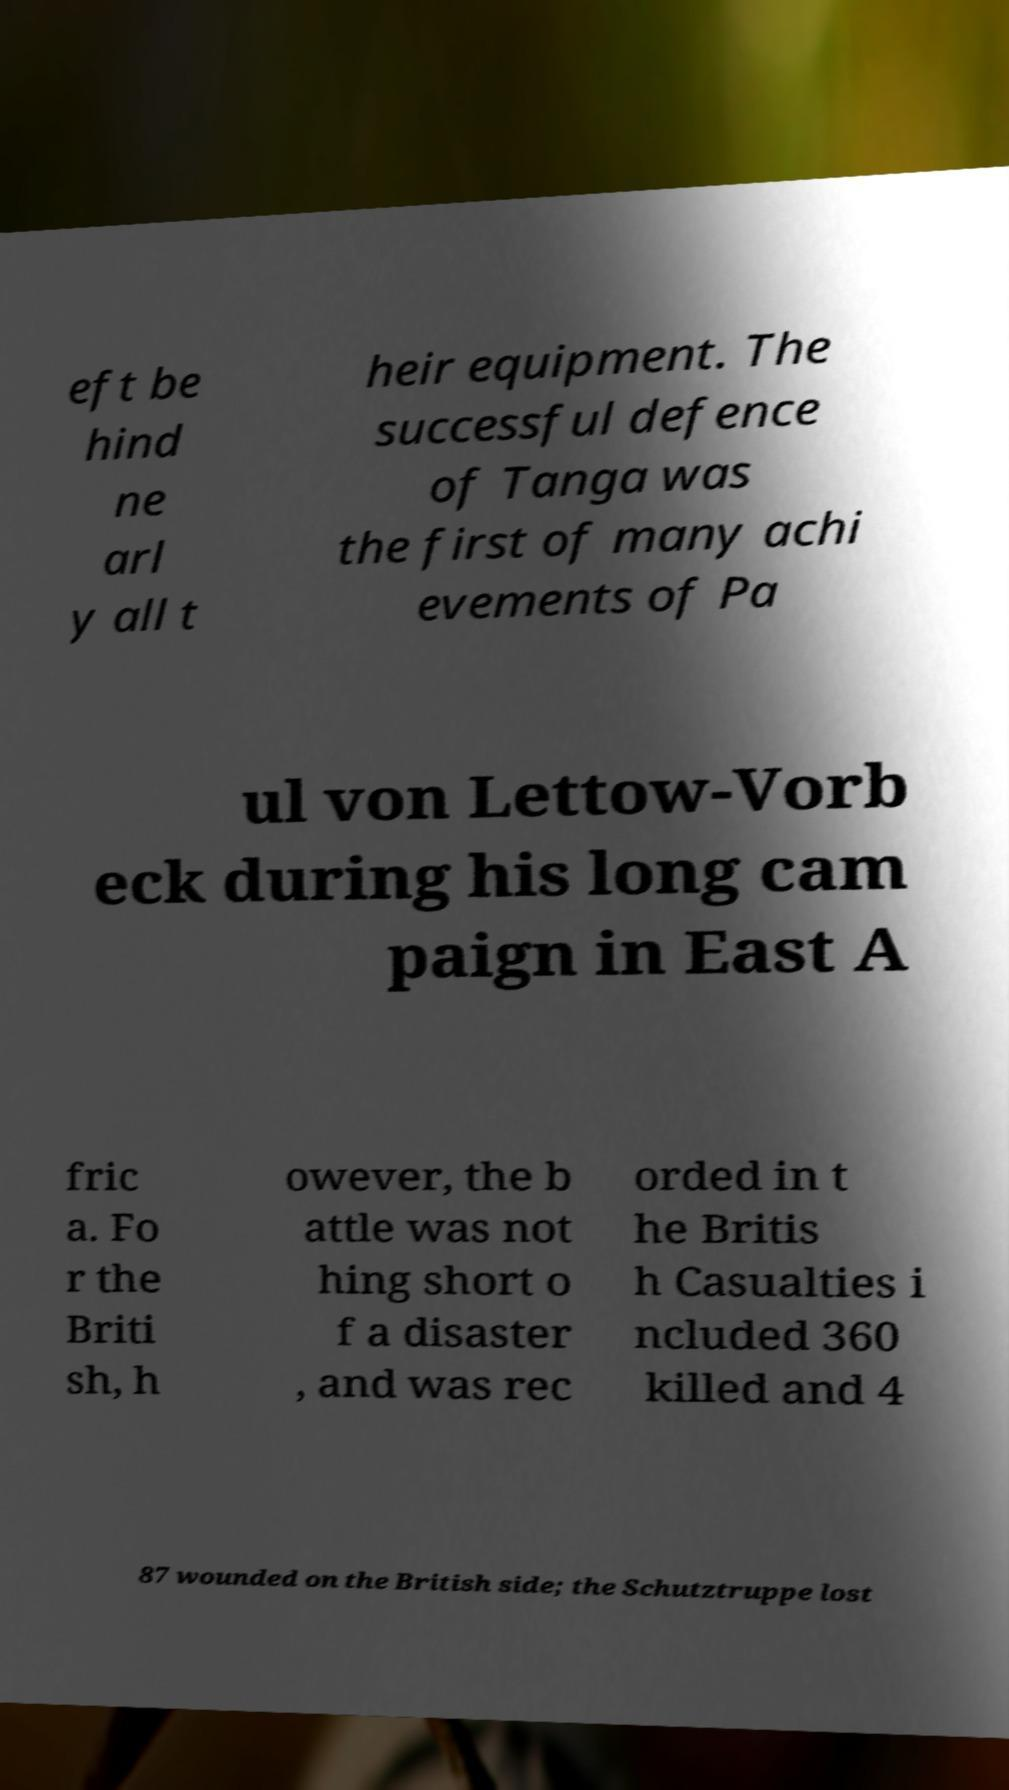Can you read and provide the text displayed in the image?This photo seems to have some interesting text. Can you extract and type it out for me? eft be hind ne arl y all t heir equipment. The successful defence of Tanga was the first of many achi evements of Pa ul von Lettow-Vorb eck during his long cam paign in East A fric a. Fo r the Briti sh, h owever, the b attle was not hing short o f a disaster , and was rec orded in t he Britis h Casualties i ncluded 360 killed and 4 87 wounded on the British side; the Schutztruppe lost 